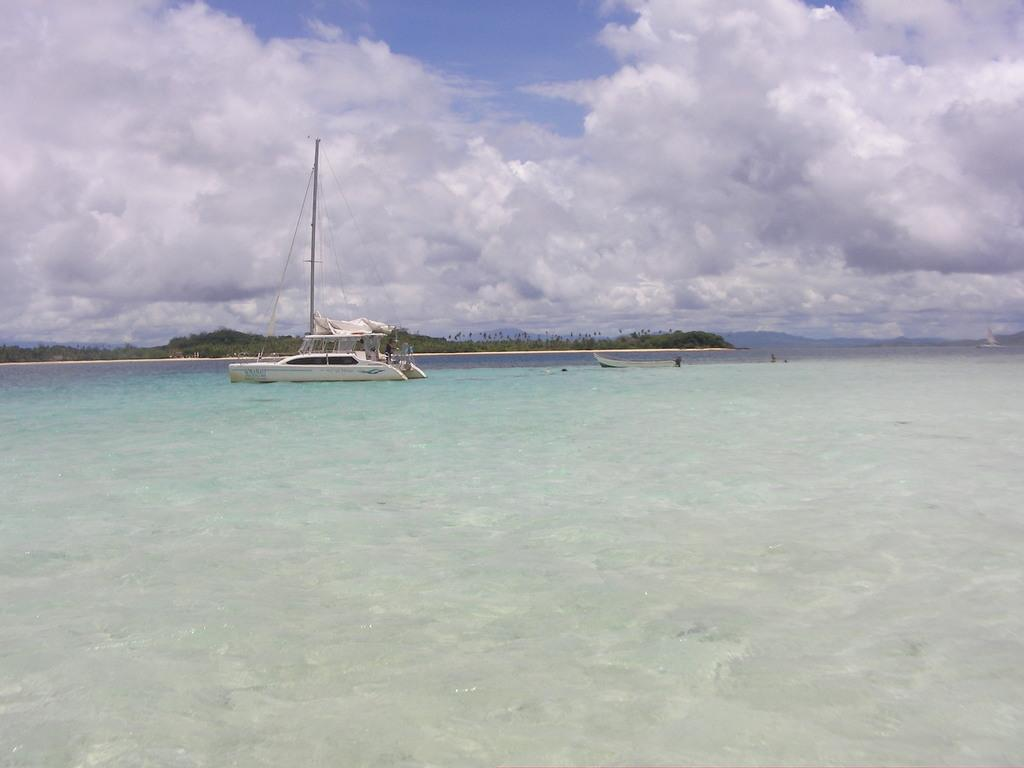What is the main subject of the image? The main subject of the image is water. What is on the water in the image? There is a boat on the water in the image. What features does the boat have? The boat has a pole and ropes. What can be seen in the background of the image? There are trees visible in the image, and the sky is visible at the top of the image. What is the condition of the sky in the image? The sky has clouds in the image. What type of wine is being served on the boat in the image? There is no wine present in the image; it features a boat on water with a pole and ropes. How many police officers are visible on the boat in the image? There are no police officers present in the image; it only shows a boat on water with a pole and ropes. 